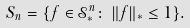Convert formula to latex. <formula><loc_0><loc_0><loc_500><loc_500>S _ { n } = \{ f \in \mathcal { S } ^ { n } _ { * } \colon \, \| f \| _ { * } \leq 1 \} .</formula> 